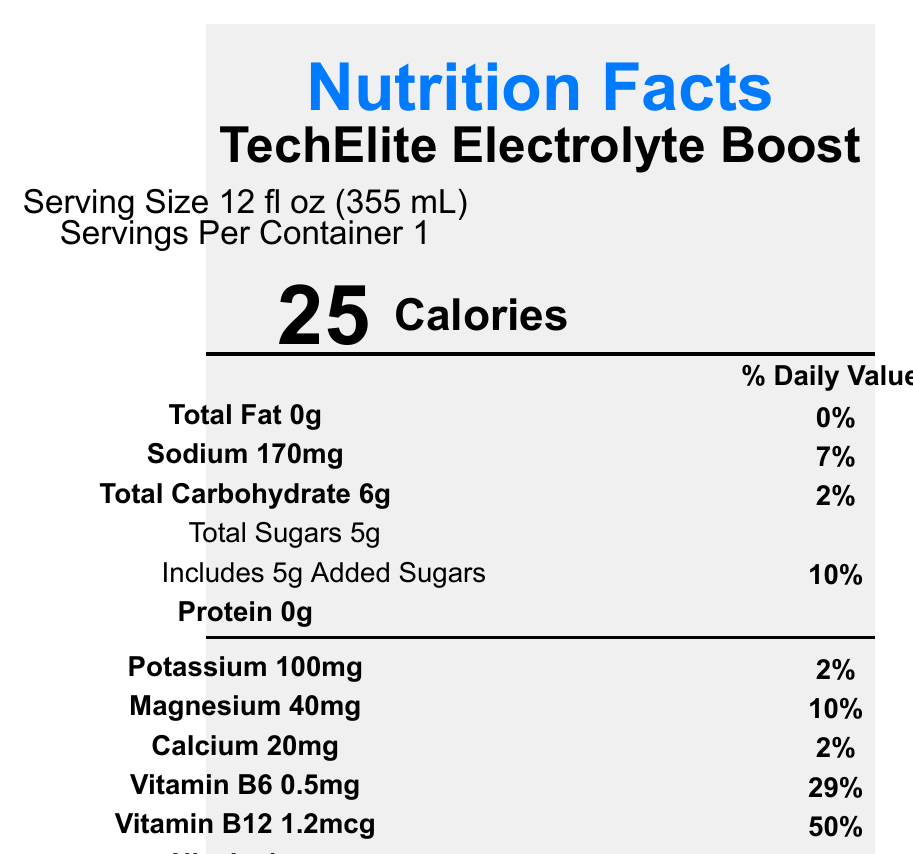what is the serving size? The serving size is explicitly mentioned as 12 fl oz (355 mL) in the document.
Answer: 12 fl oz (355 mL) how many calories are in one serving? The document states that there are 25 calories per serving.
Answer: 25 calories what is the amount of sodium in one serving? The amount of sodium per serving is listed as 170mg in the document.
Answer: 170mg what is the daily value percentage for added sugars? According to the document, the daily value percentage for added sugars is 10%.
Answer: 10% what certifications does the product have? The document lists the certifications as Non-GMO Project Verified, Vegan, and Gluten-Free.
Answer: Non-GMO Project Verified, Vegan, Gluten-Free what does Vitamin B6 contribute to the daily value percentage? The document reads that Vitamin B6 contributes 29% to the daily value percentage.
Answer: 29% which of the following is not an ingredient in the TechElite Electrolyte Boost? A) Sodium Citrate B) Potassium Chloride C) Sugar Alcohols D) Citric Acid Sugar alcohols are not listed among the ingredients in the document.
Answer: C) Sugar Alcohols how many grams of total carbohydrate are in one serving? A) 2g B) 5g C) 6g D) 10g The document states that there are 6 grams of total carbohydrate per serving.
Answer: C) 6g is the product suitable for vegans? The document mentions that the product is certified as Vegan.
Answer: Yes summarize the main idea of the document. The document is a comprehensive nutrition facts label detailing the nutritional content, ingredients, and various claims related to TechElite Electrolyte Boost.
Answer: The document provides the nutrition facts for TechElite Electrolyte Boost, a specialized electrolyte drink formulated for businesswomen in tech. It includes details on serving size, calories, macronutrients, micronutrients, ingredients, functional claims, certifications, manufacturer info, storage instructions, and recycling info. where is TechNutrition Labs located? The document specifies that TechNutrition Labs is located in San Francisco, CA 94107.
Answer: San Francisco, CA 94107 what is the main function of the product according to the functional claims? The document lists the functional claims as supporting cognitive function, promoting hydration, and enhancing focus during long work hours.
Answer: Supports cognitive function, promotes hydration, enhances focus during long work hours does the product contain protein? The document explicitly mentions that the product contains 0g of protein.
Answer: 0g what is the daily value percentage of magnesium? The daily value percentage of magnesium is noted as 10% in the document.
Answer: 10% how should the product be stored after opening? The storage instructions indicate the product should be refrigerated after opening and consumed within 3 days.
Answer: Refrigerate after opening. Consume within 3 days. is the bottle made from recycled materials? The document states that the bottle is made from 100% recycled materials and encourages recycling.
Answer: Yes how many servings are there per container? The document indicates that there is 1 serving per container.
Answer: 1 what are the main ingredients of the TechElite Electrolyte Boost? The document lists these ingredients in detail.
Answer: Purified Water, Organic Cane Sugar, Natural Flavors, Citric Acid, Sodium Citrate, Potassium Chloride, Magnesium Lactate, Calcium Lactate, Niacinamide, Pyridoxine Hydrochloride (Vitamin B6), Cyanocobalamin (Vitamin B12) what is the address of TechNutrition Labs? The document provides the city and zip code but does not include the full address with a street name and number, so the complete address cannot be determined.
Answer: Cannot be determined 